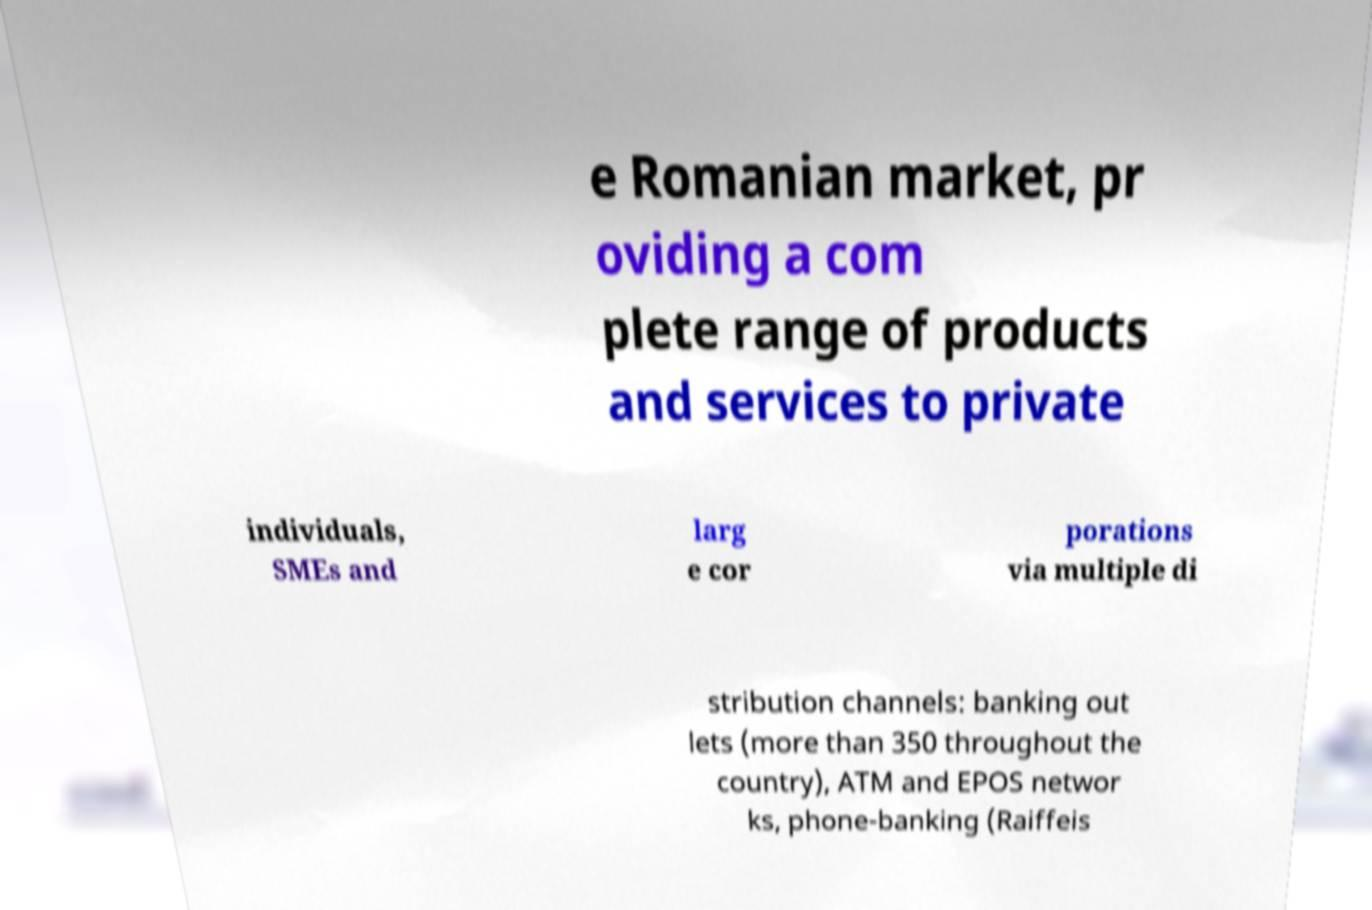What messages or text are displayed in this image? I need them in a readable, typed format. e Romanian market, pr oviding a com plete range of products and services to private individuals, SMEs and larg e cor porations via multiple di stribution channels: banking out lets (more than 350 throughout the country), ATM and EPOS networ ks, phone-banking (Raiffeis 